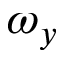Convert formula to latex. <formula><loc_0><loc_0><loc_500><loc_500>\omega _ { y }</formula> 